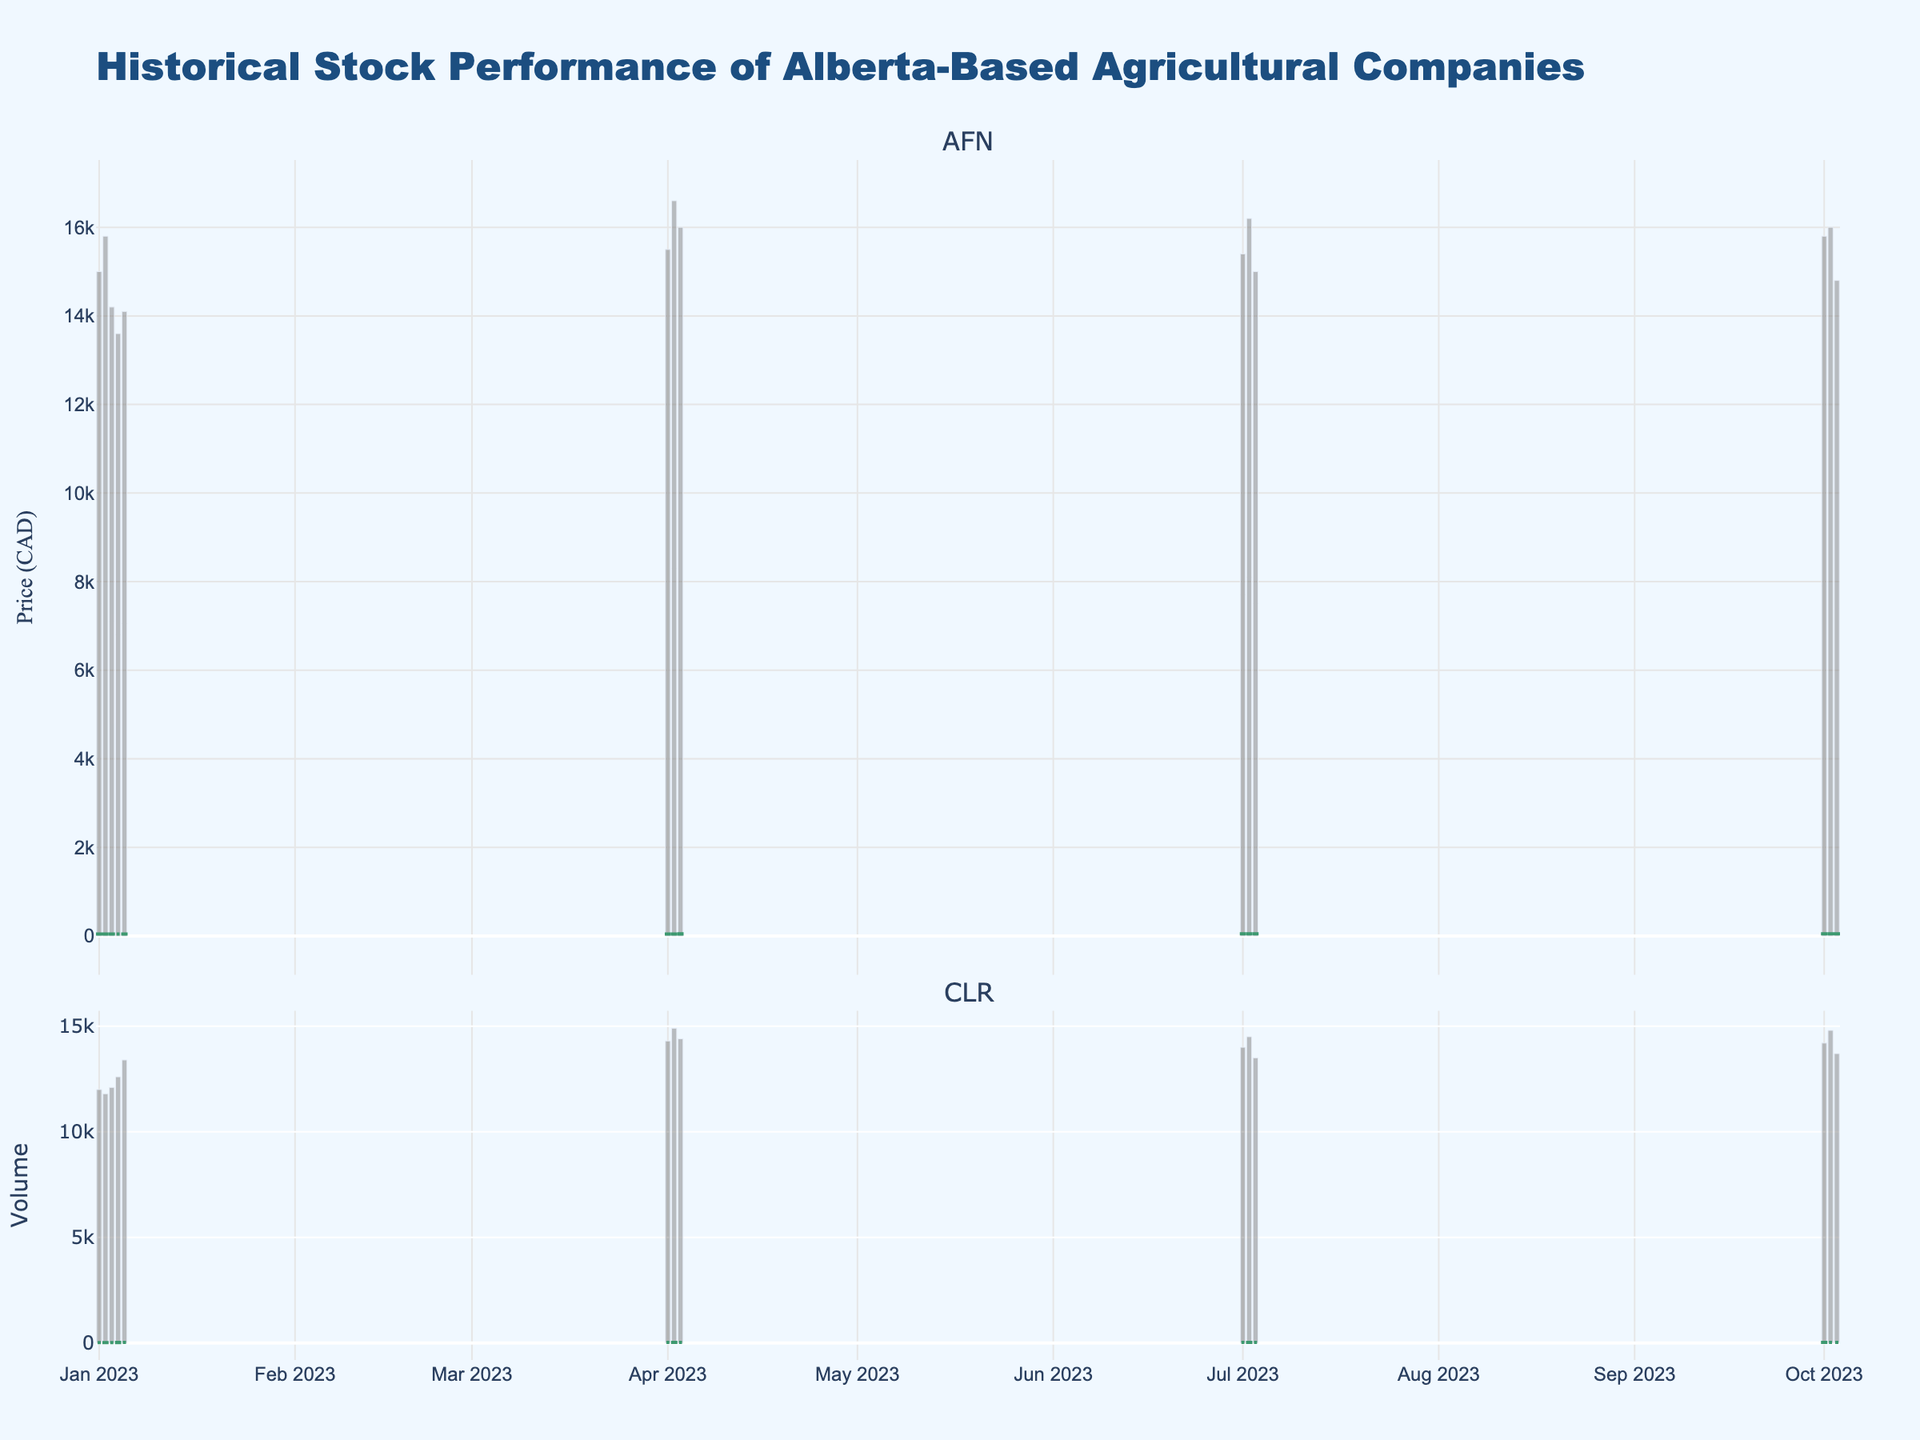What is the title of the figure? The title is usually found at the top of the chart and provides a summary of what the figure represents. In this case, it is "Historical Stock Performance of Alberta-Based Agricultural Companies".
Answer: Historical Stock Performance of Alberta-Based Agricultural Companies What are the two companies compared in the figure? The two companies' stock performances are shown in separate subplots according to their tickers. The subplot titles indicate the companies.
Answer: AFN and CLR Which company has a higher closing price on October 3, 2023? To compare closing prices, look at the candlestick chart for both companies on October 3, 2023. For AFN, the closing price is 51.5, and for CLR, it is 29.5.
Answer: AFN How did the volume of AFN stock change from April 1, 2023, to April 3, 2023? Look at the bar chart associated with AFN for the dates April 1 to April 3, 2023. The volume on April 1 is 15500, on April 2 it is 16600, and on April 3 it is 16000. Calculate the changes each day.
Answer: Increased by 1100 on April 2, decreased by 600 on April 3 Which month's stock data for CLR shows the highest closing price in 2023? Check the candlestick chart for CLR and identify the closing prices across different months in 2023. Compare each month's highest closing price.
Answer: October During which season (Months: January, April, July, October) did AFN consistently show increasing stock prices over consecutive days? Analyze the candlestick patterns for each season. If the closing prices are higher day by day over consecutive days, it indicates a consistent increase.
Answer: January What's the largest single-day price increase for CLR and on which date did it occur? Look for the largest difference between the closing price of one day and the closing price of the previous day in CLR's candlestick chart. Calculate for each day and identify the maximum.
Answer: 0.5 on April 2 Which company exhibited higher volatility in stock prices in the month of January 2023? Volatility can be indicated by the size of the candlesticks (range between high and low prices). Compare the height and changes in the candlesticks for both AFN and CLR in January.
Answer: AFN What is the trend of AFN's stock closing prices across the four seasons in 2023? Observe the closing prices of AFN across January, April, July, and October to identify the overall trend.
Answer: Upward trend Which season shows the highest trading volume for CLR and what is the specific volume? Check the bar chart representing CLR's trading volume for each season. Identify the season with the highest single volume bar.
Answer: April, 14900 